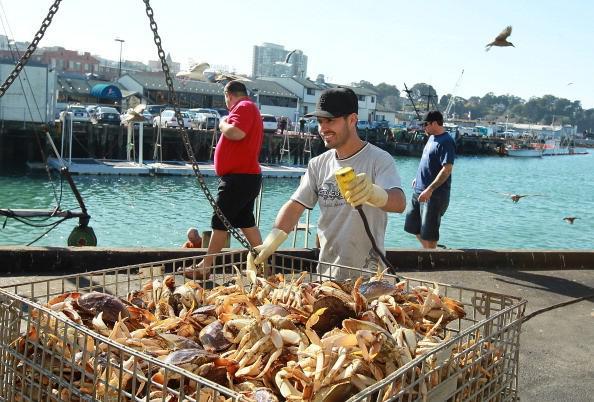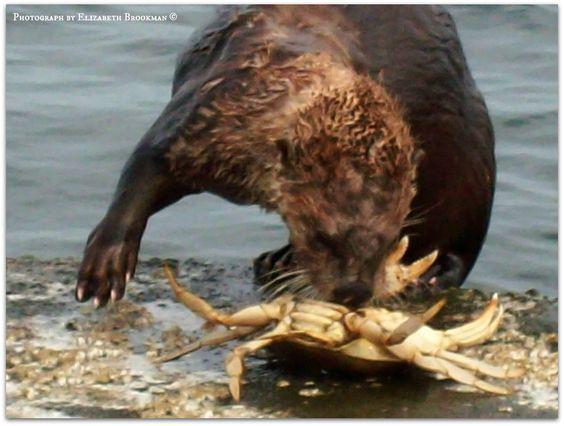The first image is the image on the left, the second image is the image on the right. Assess this claim about the two images: "At least one crab is in the wild.". Correct or not? Answer yes or no. Yes. The first image is the image on the left, the second image is the image on the right. Analyze the images presented: Is the assertion "Each image shows purplish-gray crabs in a container made of mesh attached to a frame." valid? Answer yes or no. No. 